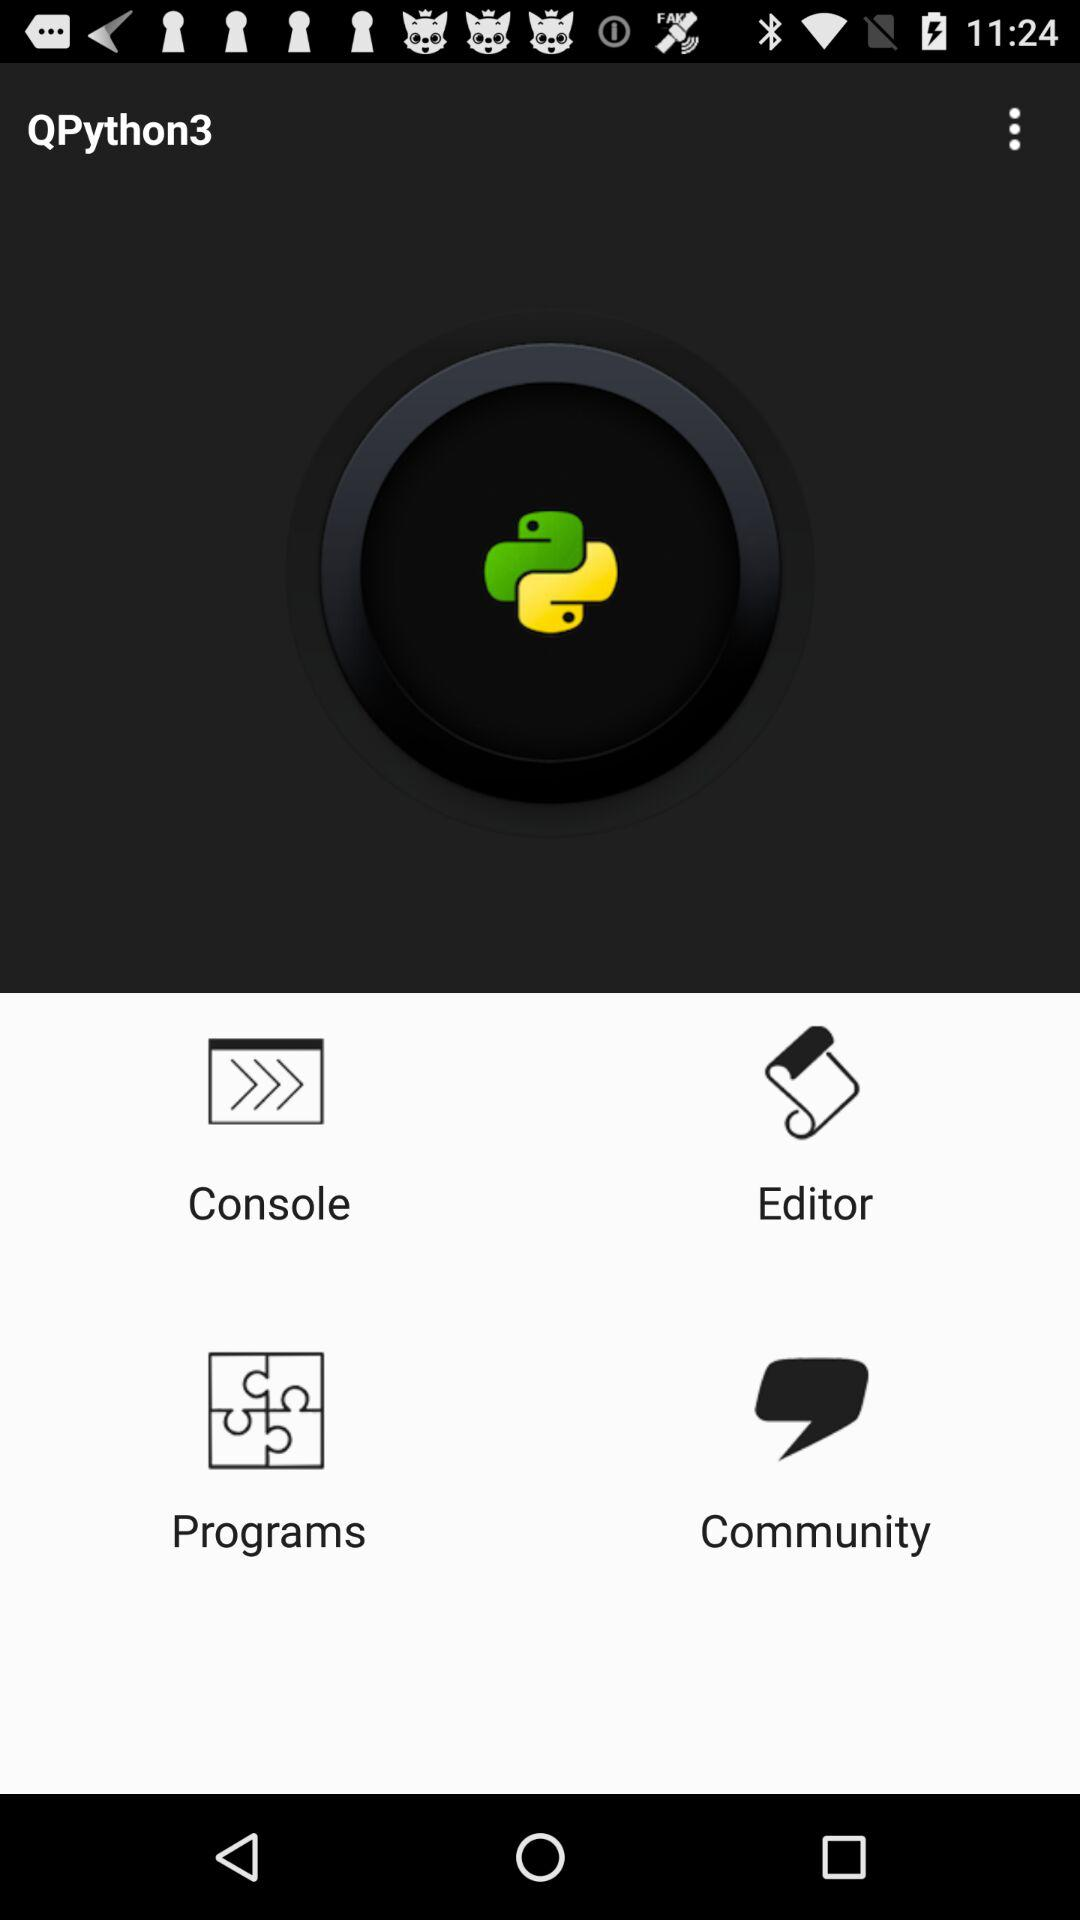What is the user's name?
When the provided information is insufficient, respond with <no answer>. <no answer> 